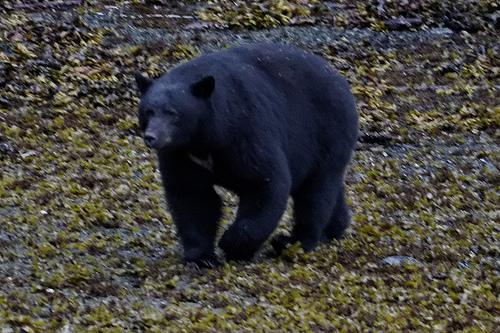Question: where is the bear?
Choices:
A. Behind the fence.
B. Next to the tree.
C. In the field.
D. In the woods.
Answer with the letter. Answer: D Question: who is in the picture?
Choices:
A. An elk.
B. A squirrel.
C. A hawk.
D. A bear.
Answer with the letter. Answer: D Question: what type of bear?
Choices:
A. Black bear.
B. Brown bear.
C. Grizzly bear.
D. Polar bear.
Answer with the letter. Answer: A Question: what is a bear?
Choices:
A. An animal that fishes.
B. A forest dweller.
C. A mammal.
D. A plant eater.
Answer with the letter. Answer: C 